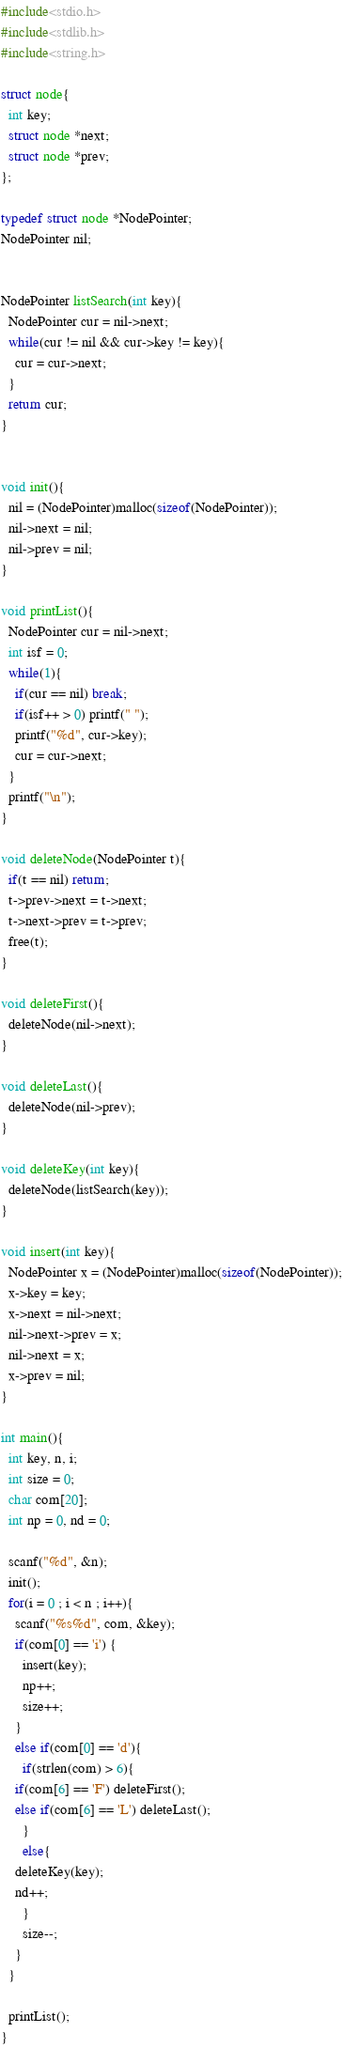<code> <loc_0><loc_0><loc_500><loc_500><_C_>#include<stdio.h>
#include<stdlib.h>
#include<string.h>

struct node{
  int key;
  struct node *next;
  struct node *prev;
};

typedef struct node *NodePointer;
NodePointer nil;


NodePointer listSearch(int key){
  NodePointer cur = nil->next;
  while(cur != nil && cur->key != key){
    cur = cur->next;
  }
  return cur;
}


void init(){
  nil = (NodePointer)malloc(sizeof(NodePointer));
  nil->next = nil;
  nil->prev = nil;
}

void printList(){
  NodePointer cur = nil->next;
  int isf = 0;
  while(1){
    if(cur == nil) break;
    if(isf++ > 0) printf(" ");
    printf("%d", cur->key);
    cur = cur->next;
  }
  printf("\n");
}

void deleteNode(NodePointer t){
  if(t == nil) return;
  t->prev->next = t->next;
  t->next->prev = t->prev;
  free(t);
}

void deleteFirst(){
  deleteNode(nil->next);
}

void deleteLast(){
  deleteNode(nil->prev);
}

void deleteKey(int key){
  deleteNode(listSearch(key));
}

void insert(int key){
  NodePointer x = (NodePointer)malloc(sizeof(NodePointer));
  x->key = key;
  x->next = nil->next;
  nil->next->prev = x;
  nil->next = x;
  x->prev = nil;
}

int main(){
  int key, n, i;
  int size = 0;
  char com[20];
  int np = 0, nd = 0;
  
  scanf("%d", &n);
  init();
  for(i = 0 ; i < n ; i++){
    scanf("%s%d", com, &key);
    if(com[0] == 'i') {
      insert(key);
      np++;
      size++;
    }
    else if(com[0] == 'd'){
      if(strlen(com) > 6){
	if(com[6] == 'F') deleteFirst();
	else if(com[6] == 'L') deleteLast();
      }
      else{
	deleteKey(key);
	nd++;
      }
      size--;
    }
  }

  printList();
}
</code> 